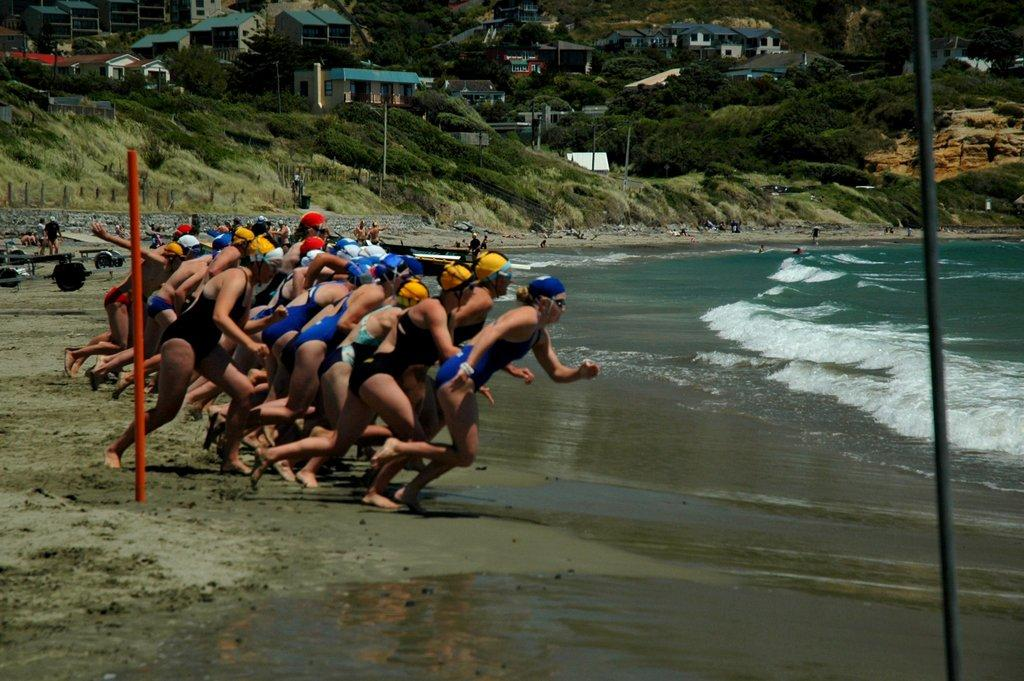What are the people in the image doing? The persons in the image are standing and running. Where is the image located? The location is the seashore. What can be seen in the background of the image? There is a sea, hills, buildings, and trees visible in the image. What type of glue is being used by the person in the image? There is no glue present in the image, and no person is shown using any glue. How does the mouth of the person in the image look like? There are no close-up shots of any person's mouth in the image, so it cannot be determined how it looks. 